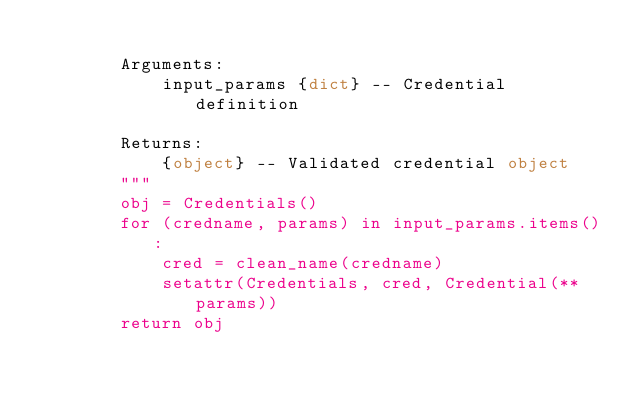Convert code to text. <code><loc_0><loc_0><loc_500><loc_500><_Python_>
        Arguments:
            input_params {dict} -- Credential definition

        Returns:
            {object} -- Validated credential object
        """
        obj = Credentials()
        for (credname, params) in input_params.items():
            cred = clean_name(credname)
            setattr(Credentials, cred, Credential(**params))
        return obj
</code> 